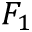Convert formula to latex. <formula><loc_0><loc_0><loc_500><loc_500>F _ { 1 }</formula> 